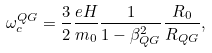<formula> <loc_0><loc_0><loc_500><loc_500>\omega _ { c } ^ { Q G } = \frac { 3 } { 2 } \frac { e H } { m _ { 0 } } \frac { 1 } { 1 - \beta _ { Q G } ^ { 2 } } \frac { R _ { 0 } } { R _ { Q G } } ,</formula> 